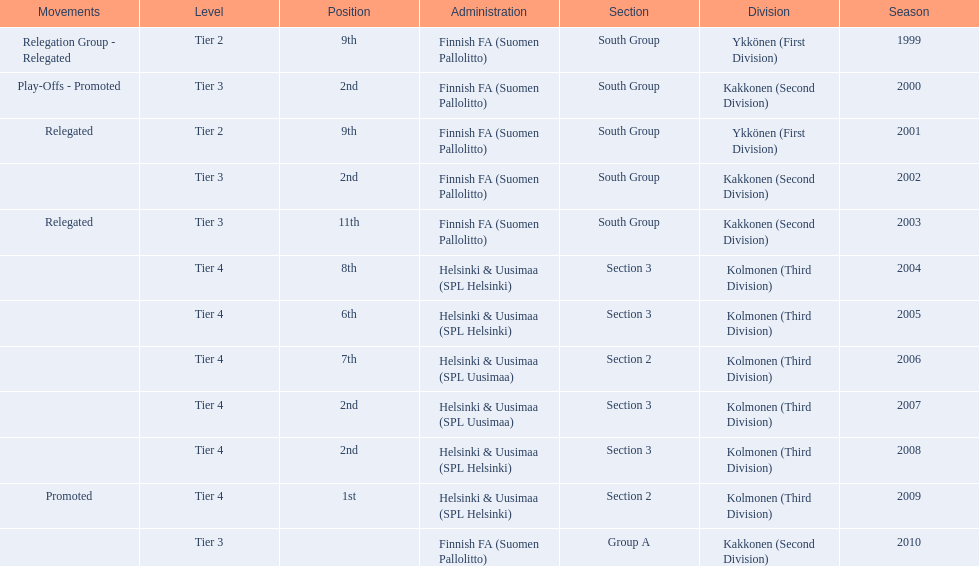Which administration has the minimal amount of separation? Helsinki & Uusimaa (SPL Helsinki). 